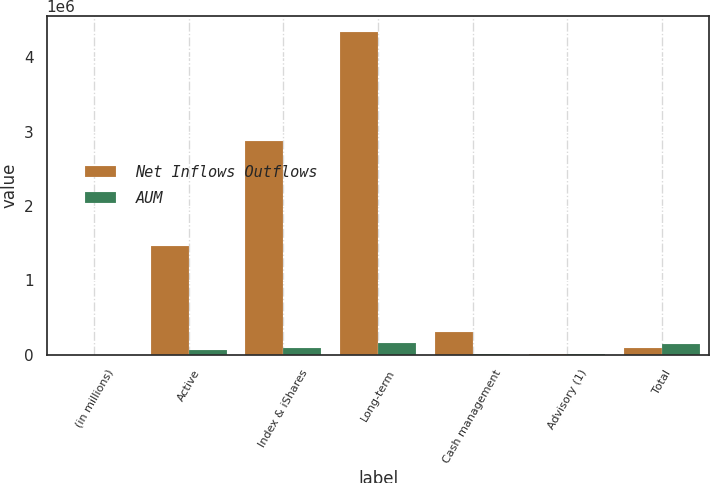<chart> <loc_0><loc_0><loc_500><loc_500><stacked_bar_chart><ecel><fcel>(in millions)<fcel>Active<fcel>Index & iShares<fcel>Long-term<fcel>Cash management<fcel>Advisory (1)<fcel>Total<nl><fcel>Net Inflows Outflows<fcel>2015<fcel>1.46267e+06<fcel>2.87264e+06<fcel>4.33532e+06<fcel>299884<fcel>10213<fcel>91504<nl><fcel>AUM<fcel>2015<fcel>60510<fcel>91504<fcel>152014<fcel>7510<fcel>9629<fcel>149895<nl></chart> 